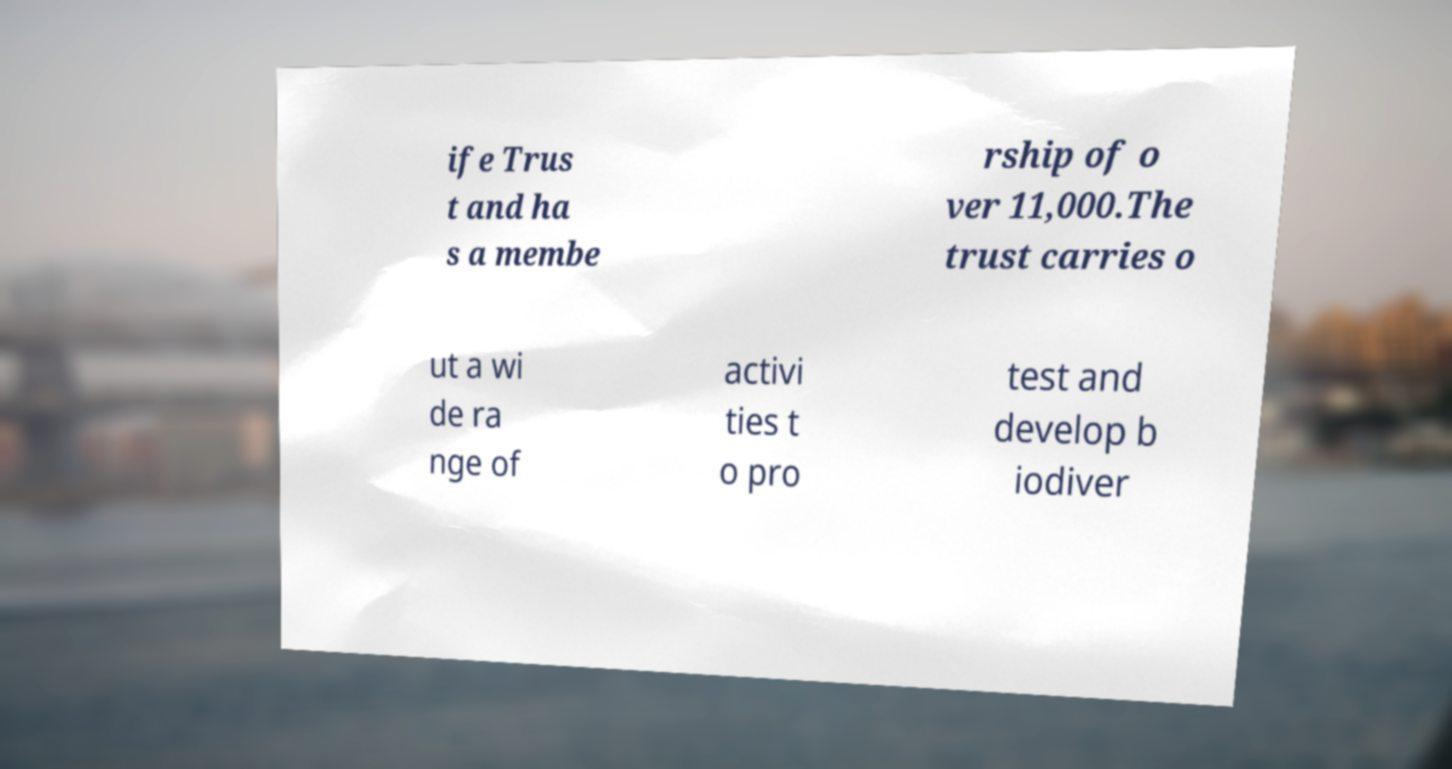There's text embedded in this image that I need extracted. Can you transcribe it verbatim? ife Trus t and ha s a membe rship of o ver 11,000.The trust carries o ut a wi de ra nge of activi ties t o pro test and develop b iodiver 